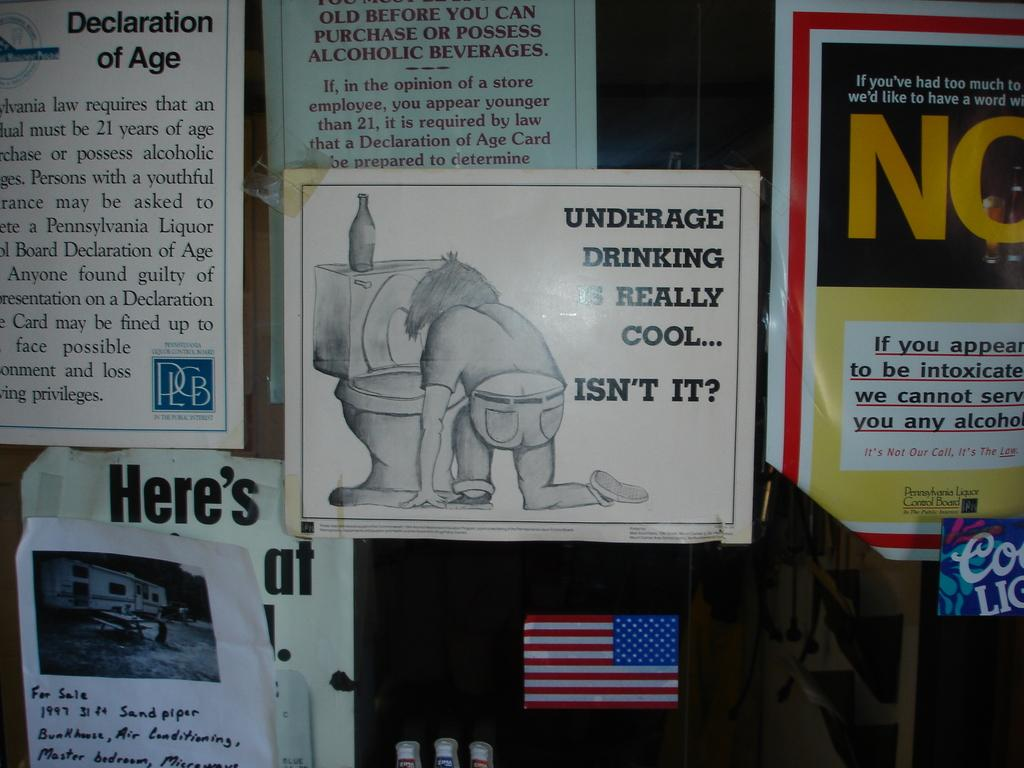<image>
Summarize the visual content of the image. A poster that talks about how not cool underage drinking is 